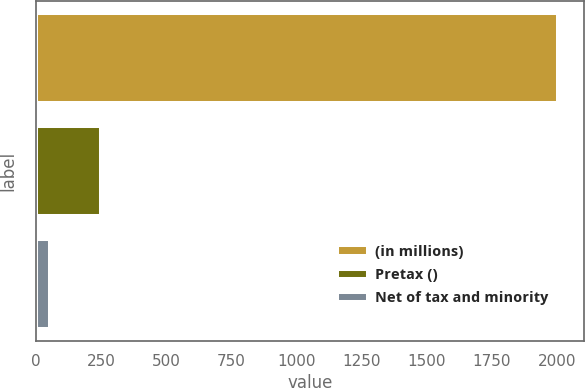Convert chart to OTSL. <chart><loc_0><loc_0><loc_500><loc_500><bar_chart><fcel>(in millions)<fcel>Pretax ()<fcel>Net of tax and minority<nl><fcel>2003<fcel>248<fcel>53<nl></chart> 